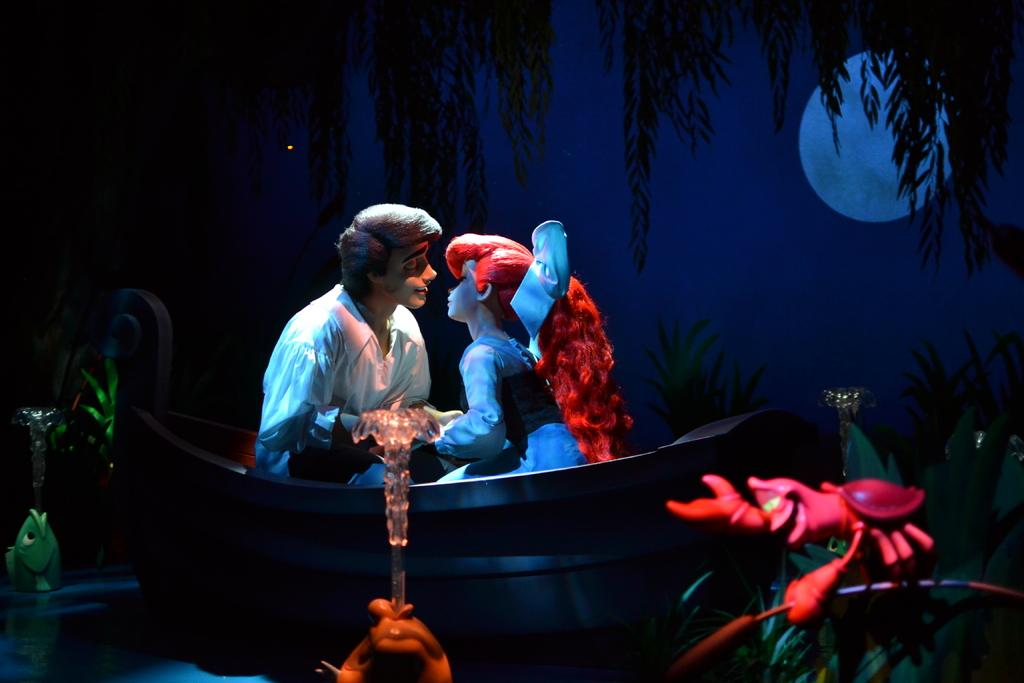What is happening in the animated picture in the image? There are two people sitting in the animated picture in the image. What are the people wearing? The people are wearing clothes. What can be seen in the background of the image? There is water, trees, the moon, and the sky visible in the image. What is the income of the people in the image? There is no information about the income of the people in the image. Do the people have fangs in the image? There are no fangs visible on the people in the image. 